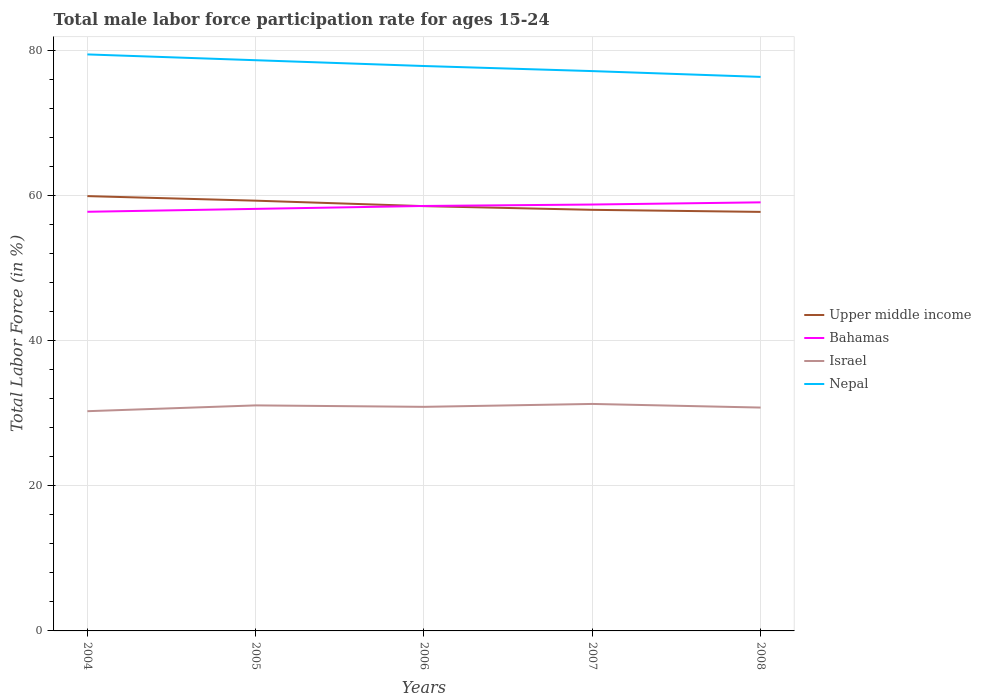Does the line corresponding to Nepal intersect with the line corresponding to Israel?
Offer a very short reply. No. Is the number of lines equal to the number of legend labels?
Provide a succinct answer. Yes. Across all years, what is the maximum male labor force participation rate in Upper middle income?
Ensure brevity in your answer.  57.78. In which year was the male labor force participation rate in Bahamas maximum?
Your answer should be very brief. 2004. What is the total male labor force participation rate in Bahamas in the graph?
Your answer should be compact. -0.6. What is the difference between the highest and the second highest male labor force participation rate in Nepal?
Ensure brevity in your answer.  3.1. What is the difference between the highest and the lowest male labor force participation rate in Bahamas?
Make the answer very short. 3. Is the male labor force participation rate in Upper middle income strictly greater than the male labor force participation rate in Nepal over the years?
Provide a short and direct response. Yes. What is the difference between two consecutive major ticks on the Y-axis?
Make the answer very short. 20. Does the graph contain grids?
Provide a succinct answer. Yes. Where does the legend appear in the graph?
Provide a succinct answer. Center right. What is the title of the graph?
Provide a succinct answer. Total male labor force participation rate for ages 15-24. Does "Paraguay" appear as one of the legend labels in the graph?
Offer a terse response. No. What is the label or title of the X-axis?
Offer a terse response. Years. What is the Total Labor Force (in %) in Upper middle income in 2004?
Offer a terse response. 59.96. What is the Total Labor Force (in %) of Bahamas in 2004?
Offer a very short reply. 57.8. What is the Total Labor Force (in %) in Israel in 2004?
Provide a succinct answer. 30.3. What is the Total Labor Force (in %) of Nepal in 2004?
Your answer should be very brief. 79.5. What is the Total Labor Force (in %) in Upper middle income in 2005?
Your answer should be compact. 59.33. What is the Total Labor Force (in %) of Bahamas in 2005?
Keep it short and to the point. 58.2. What is the Total Labor Force (in %) of Israel in 2005?
Make the answer very short. 31.1. What is the Total Labor Force (in %) in Nepal in 2005?
Ensure brevity in your answer.  78.7. What is the Total Labor Force (in %) in Upper middle income in 2006?
Make the answer very short. 58.58. What is the Total Labor Force (in %) of Bahamas in 2006?
Your answer should be very brief. 58.6. What is the Total Labor Force (in %) in Israel in 2006?
Offer a very short reply. 30.9. What is the Total Labor Force (in %) in Nepal in 2006?
Your answer should be very brief. 77.9. What is the Total Labor Force (in %) in Upper middle income in 2007?
Provide a succinct answer. 58.07. What is the Total Labor Force (in %) of Bahamas in 2007?
Provide a succinct answer. 58.8. What is the Total Labor Force (in %) of Israel in 2007?
Make the answer very short. 31.3. What is the Total Labor Force (in %) of Nepal in 2007?
Give a very brief answer. 77.2. What is the Total Labor Force (in %) of Upper middle income in 2008?
Your response must be concise. 57.78. What is the Total Labor Force (in %) of Bahamas in 2008?
Ensure brevity in your answer.  59.1. What is the Total Labor Force (in %) of Israel in 2008?
Your answer should be compact. 30.8. What is the Total Labor Force (in %) in Nepal in 2008?
Ensure brevity in your answer.  76.4. Across all years, what is the maximum Total Labor Force (in %) in Upper middle income?
Offer a very short reply. 59.96. Across all years, what is the maximum Total Labor Force (in %) in Bahamas?
Ensure brevity in your answer.  59.1. Across all years, what is the maximum Total Labor Force (in %) in Israel?
Keep it short and to the point. 31.3. Across all years, what is the maximum Total Labor Force (in %) of Nepal?
Your answer should be very brief. 79.5. Across all years, what is the minimum Total Labor Force (in %) in Upper middle income?
Your answer should be very brief. 57.78. Across all years, what is the minimum Total Labor Force (in %) in Bahamas?
Keep it short and to the point. 57.8. Across all years, what is the minimum Total Labor Force (in %) in Israel?
Your answer should be very brief. 30.3. Across all years, what is the minimum Total Labor Force (in %) in Nepal?
Your answer should be compact. 76.4. What is the total Total Labor Force (in %) of Upper middle income in the graph?
Keep it short and to the point. 293.72. What is the total Total Labor Force (in %) in Bahamas in the graph?
Provide a succinct answer. 292.5. What is the total Total Labor Force (in %) in Israel in the graph?
Offer a terse response. 154.4. What is the total Total Labor Force (in %) in Nepal in the graph?
Ensure brevity in your answer.  389.7. What is the difference between the Total Labor Force (in %) in Upper middle income in 2004 and that in 2005?
Make the answer very short. 0.63. What is the difference between the Total Labor Force (in %) in Upper middle income in 2004 and that in 2006?
Keep it short and to the point. 1.38. What is the difference between the Total Labor Force (in %) of Bahamas in 2004 and that in 2006?
Make the answer very short. -0.8. What is the difference between the Total Labor Force (in %) in Nepal in 2004 and that in 2006?
Make the answer very short. 1.6. What is the difference between the Total Labor Force (in %) of Upper middle income in 2004 and that in 2007?
Offer a very short reply. 1.89. What is the difference between the Total Labor Force (in %) of Israel in 2004 and that in 2007?
Keep it short and to the point. -1. What is the difference between the Total Labor Force (in %) in Nepal in 2004 and that in 2007?
Your answer should be compact. 2.3. What is the difference between the Total Labor Force (in %) of Upper middle income in 2004 and that in 2008?
Your answer should be very brief. 2.17. What is the difference between the Total Labor Force (in %) in Bahamas in 2004 and that in 2008?
Provide a succinct answer. -1.3. What is the difference between the Total Labor Force (in %) of Israel in 2004 and that in 2008?
Provide a short and direct response. -0.5. What is the difference between the Total Labor Force (in %) of Upper middle income in 2005 and that in 2006?
Give a very brief answer. 0.75. What is the difference between the Total Labor Force (in %) in Bahamas in 2005 and that in 2006?
Offer a terse response. -0.4. What is the difference between the Total Labor Force (in %) in Upper middle income in 2005 and that in 2007?
Offer a very short reply. 1.26. What is the difference between the Total Labor Force (in %) of Nepal in 2005 and that in 2007?
Provide a short and direct response. 1.5. What is the difference between the Total Labor Force (in %) of Upper middle income in 2005 and that in 2008?
Offer a very short reply. 1.55. What is the difference between the Total Labor Force (in %) in Bahamas in 2005 and that in 2008?
Provide a short and direct response. -0.9. What is the difference between the Total Labor Force (in %) of Nepal in 2005 and that in 2008?
Make the answer very short. 2.3. What is the difference between the Total Labor Force (in %) in Upper middle income in 2006 and that in 2007?
Offer a very short reply. 0.51. What is the difference between the Total Labor Force (in %) in Israel in 2006 and that in 2007?
Your response must be concise. -0.4. What is the difference between the Total Labor Force (in %) in Nepal in 2006 and that in 2007?
Ensure brevity in your answer.  0.7. What is the difference between the Total Labor Force (in %) of Upper middle income in 2006 and that in 2008?
Ensure brevity in your answer.  0.79. What is the difference between the Total Labor Force (in %) in Israel in 2006 and that in 2008?
Offer a terse response. 0.1. What is the difference between the Total Labor Force (in %) in Upper middle income in 2007 and that in 2008?
Your answer should be very brief. 0.28. What is the difference between the Total Labor Force (in %) in Bahamas in 2007 and that in 2008?
Ensure brevity in your answer.  -0.3. What is the difference between the Total Labor Force (in %) in Upper middle income in 2004 and the Total Labor Force (in %) in Bahamas in 2005?
Give a very brief answer. 1.76. What is the difference between the Total Labor Force (in %) of Upper middle income in 2004 and the Total Labor Force (in %) of Israel in 2005?
Offer a very short reply. 28.86. What is the difference between the Total Labor Force (in %) of Upper middle income in 2004 and the Total Labor Force (in %) of Nepal in 2005?
Your response must be concise. -18.74. What is the difference between the Total Labor Force (in %) of Bahamas in 2004 and the Total Labor Force (in %) of Israel in 2005?
Provide a short and direct response. 26.7. What is the difference between the Total Labor Force (in %) of Bahamas in 2004 and the Total Labor Force (in %) of Nepal in 2005?
Offer a very short reply. -20.9. What is the difference between the Total Labor Force (in %) in Israel in 2004 and the Total Labor Force (in %) in Nepal in 2005?
Your answer should be compact. -48.4. What is the difference between the Total Labor Force (in %) in Upper middle income in 2004 and the Total Labor Force (in %) in Bahamas in 2006?
Give a very brief answer. 1.36. What is the difference between the Total Labor Force (in %) in Upper middle income in 2004 and the Total Labor Force (in %) in Israel in 2006?
Keep it short and to the point. 29.06. What is the difference between the Total Labor Force (in %) in Upper middle income in 2004 and the Total Labor Force (in %) in Nepal in 2006?
Give a very brief answer. -17.94. What is the difference between the Total Labor Force (in %) in Bahamas in 2004 and the Total Labor Force (in %) in Israel in 2006?
Your answer should be compact. 26.9. What is the difference between the Total Labor Force (in %) in Bahamas in 2004 and the Total Labor Force (in %) in Nepal in 2006?
Offer a terse response. -20.1. What is the difference between the Total Labor Force (in %) of Israel in 2004 and the Total Labor Force (in %) of Nepal in 2006?
Offer a very short reply. -47.6. What is the difference between the Total Labor Force (in %) of Upper middle income in 2004 and the Total Labor Force (in %) of Bahamas in 2007?
Your response must be concise. 1.16. What is the difference between the Total Labor Force (in %) of Upper middle income in 2004 and the Total Labor Force (in %) of Israel in 2007?
Your answer should be very brief. 28.66. What is the difference between the Total Labor Force (in %) in Upper middle income in 2004 and the Total Labor Force (in %) in Nepal in 2007?
Keep it short and to the point. -17.24. What is the difference between the Total Labor Force (in %) in Bahamas in 2004 and the Total Labor Force (in %) in Nepal in 2007?
Your answer should be very brief. -19.4. What is the difference between the Total Labor Force (in %) of Israel in 2004 and the Total Labor Force (in %) of Nepal in 2007?
Offer a very short reply. -46.9. What is the difference between the Total Labor Force (in %) in Upper middle income in 2004 and the Total Labor Force (in %) in Bahamas in 2008?
Give a very brief answer. 0.86. What is the difference between the Total Labor Force (in %) of Upper middle income in 2004 and the Total Labor Force (in %) of Israel in 2008?
Your answer should be compact. 29.16. What is the difference between the Total Labor Force (in %) in Upper middle income in 2004 and the Total Labor Force (in %) in Nepal in 2008?
Your answer should be compact. -16.44. What is the difference between the Total Labor Force (in %) of Bahamas in 2004 and the Total Labor Force (in %) of Israel in 2008?
Make the answer very short. 27. What is the difference between the Total Labor Force (in %) of Bahamas in 2004 and the Total Labor Force (in %) of Nepal in 2008?
Offer a terse response. -18.6. What is the difference between the Total Labor Force (in %) of Israel in 2004 and the Total Labor Force (in %) of Nepal in 2008?
Ensure brevity in your answer.  -46.1. What is the difference between the Total Labor Force (in %) in Upper middle income in 2005 and the Total Labor Force (in %) in Bahamas in 2006?
Offer a terse response. 0.73. What is the difference between the Total Labor Force (in %) in Upper middle income in 2005 and the Total Labor Force (in %) in Israel in 2006?
Make the answer very short. 28.43. What is the difference between the Total Labor Force (in %) in Upper middle income in 2005 and the Total Labor Force (in %) in Nepal in 2006?
Make the answer very short. -18.57. What is the difference between the Total Labor Force (in %) of Bahamas in 2005 and the Total Labor Force (in %) of Israel in 2006?
Offer a very short reply. 27.3. What is the difference between the Total Labor Force (in %) of Bahamas in 2005 and the Total Labor Force (in %) of Nepal in 2006?
Offer a very short reply. -19.7. What is the difference between the Total Labor Force (in %) in Israel in 2005 and the Total Labor Force (in %) in Nepal in 2006?
Keep it short and to the point. -46.8. What is the difference between the Total Labor Force (in %) in Upper middle income in 2005 and the Total Labor Force (in %) in Bahamas in 2007?
Give a very brief answer. 0.53. What is the difference between the Total Labor Force (in %) in Upper middle income in 2005 and the Total Labor Force (in %) in Israel in 2007?
Provide a short and direct response. 28.03. What is the difference between the Total Labor Force (in %) in Upper middle income in 2005 and the Total Labor Force (in %) in Nepal in 2007?
Offer a very short reply. -17.87. What is the difference between the Total Labor Force (in %) of Bahamas in 2005 and the Total Labor Force (in %) of Israel in 2007?
Offer a very short reply. 26.9. What is the difference between the Total Labor Force (in %) in Bahamas in 2005 and the Total Labor Force (in %) in Nepal in 2007?
Your response must be concise. -19. What is the difference between the Total Labor Force (in %) in Israel in 2005 and the Total Labor Force (in %) in Nepal in 2007?
Your answer should be compact. -46.1. What is the difference between the Total Labor Force (in %) of Upper middle income in 2005 and the Total Labor Force (in %) of Bahamas in 2008?
Make the answer very short. 0.23. What is the difference between the Total Labor Force (in %) in Upper middle income in 2005 and the Total Labor Force (in %) in Israel in 2008?
Provide a short and direct response. 28.53. What is the difference between the Total Labor Force (in %) in Upper middle income in 2005 and the Total Labor Force (in %) in Nepal in 2008?
Ensure brevity in your answer.  -17.07. What is the difference between the Total Labor Force (in %) of Bahamas in 2005 and the Total Labor Force (in %) of Israel in 2008?
Provide a succinct answer. 27.4. What is the difference between the Total Labor Force (in %) in Bahamas in 2005 and the Total Labor Force (in %) in Nepal in 2008?
Your response must be concise. -18.2. What is the difference between the Total Labor Force (in %) of Israel in 2005 and the Total Labor Force (in %) of Nepal in 2008?
Offer a terse response. -45.3. What is the difference between the Total Labor Force (in %) of Upper middle income in 2006 and the Total Labor Force (in %) of Bahamas in 2007?
Your answer should be compact. -0.22. What is the difference between the Total Labor Force (in %) in Upper middle income in 2006 and the Total Labor Force (in %) in Israel in 2007?
Ensure brevity in your answer.  27.28. What is the difference between the Total Labor Force (in %) in Upper middle income in 2006 and the Total Labor Force (in %) in Nepal in 2007?
Keep it short and to the point. -18.62. What is the difference between the Total Labor Force (in %) of Bahamas in 2006 and the Total Labor Force (in %) of Israel in 2007?
Your response must be concise. 27.3. What is the difference between the Total Labor Force (in %) of Bahamas in 2006 and the Total Labor Force (in %) of Nepal in 2007?
Provide a succinct answer. -18.6. What is the difference between the Total Labor Force (in %) in Israel in 2006 and the Total Labor Force (in %) in Nepal in 2007?
Provide a succinct answer. -46.3. What is the difference between the Total Labor Force (in %) in Upper middle income in 2006 and the Total Labor Force (in %) in Bahamas in 2008?
Give a very brief answer. -0.52. What is the difference between the Total Labor Force (in %) in Upper middle income in 2006 and the Total Labor Force (in %) in Israel in 2008?
Your answer should be compact. 27.78. What is the difference between the Total Labor Force (in %) in Upper middle income in 2006 and the Total Labor Force (in %) in Nepal in 2008?
Provide a short and direct response. -17.82. What is the difference between the Total Labor Force (in %) of Bahamas in 2006 and the Total Labor Force (in %) of Israel in 2008?
Your answer should be very brief. 27.8. What is the difference between the Total Labor Force (in %) in Bahamas in 2006 and the Total Labor Force (in %) in Nepal in 2008?
Your answer should be compact. -17.8. What is the difference between the Total Labor Force (in %) of Israel in 2006 and the Total Labor Force (in %) of Nepal in 2008?
Your response must be concise. -45.5. What is the difference between the Total Labor Force (in %) in Upper middle income in 2007 and the Total Labor Force (in %) in Bahamas in 2008?
Ensure brevity in your answer.  -1.03. What is the difference between the Total Labor Force (in %) in Upper middle income in 2007 and the Total Labor Force (in %) in Israel in 2008?
Your response must be concise. 27.27. What is the difference between the Total Labor Force (in %) of Upper middle income in 2007 and the Total Labor Force (in %) of Nepal in 2008?
Offer a terse response. -18.33. What is the difference between the Total Labor Force (in %) in Bahamas in 2007 and the Total Labor Force (in %) in Nepal in 2008?
Provide a succinct answer. -17.6. What is the difference between the Total Labor Force (in %) of Israel in 2007 and the Total Labor Force (in %) of Nepal in 2008?
Your answer should be compact. -45.1. What is the average Total Labor Force (in %) in Upper middle income per year?
Make the answer very short. 58.74. What is the average Total Labor Force (in %) of Bahamas per year?
Give a very brief answer. 58.5. What is the average Total Labor Force (in %) of Israel per year?
Offer a very short reply. 30.88. What is the average Total Labor Force (in %) of Nepal per year?
Your answer should be very brief. 77.94. In the year 2004, what is the difference between the Total Labor Force (in %) of Upper middle income and Total Labor Force (in %) of Bahamas?
Your answer should be compact. 2.16. In the year 2004, what is the difference between the Total Labor Force (in %) in Upper middle income and Total Labor Force (in %) in Israel?
Keep it short and to the point. 29.66. In the year 2004, what is the difference between the Total Labor Force (in %) in Upper middle income and Total Labor Force (in %) in Nepal?
Your response must be concise. -19.54. In the year 2004, what is the difference between the Total Labor Force (in %) of Bahamas and Total Labor Force (in %) of Nepal?
Keep it short and to the point. -21.7. In the year 2004, what is the difference between the Total Labor Force (in %) in Israel and Total Labor Force (in %) in Nepal?
Offer a very short reply. -49.2. In the year 2005, what is the difference between the Total Labor Force (in %) of Upper middle income and Total Labor Force (in %) of Bahamas?
Ensure brevity in your answer.  1.13. In the year 2005, what is the difference between the Total Labor Force (in %) of Upper middle income and Total Labor Force (in %) of Israel?
Give a very brief answer. 28.23. In the year 2005, what is the difference between the Total Labor Force (in %) of Upper middle income and Total Labor Force (in %) of Nepal?
Keep it short and to the point. -19.37. In the year 2005, what is the difference between the Total Labor Force (in %) of Bahamas and Total Labor Force (in %) of Israel?
Keep it short and to the point. 27.1. In the year 2005, what is the difference between the Total Labor Force (in %) of Bahamas and Total Labor Force (in %) of Nepal?
Your answer should be compact. -20.5. In the year 2005, what is the difference between the Total Labor Force (in %) in Israel and Total Labor Force (in %) in Nepal?
Give a very brief answer. -47.6. In the year 2006, what is the difference between the Total Labor Force (in %) of Upper middle income and Total Labor Force (in %) of Bahamas?
Make the answer very short. -0.02. In the year 2006, what is the difference between the Total Labor Force (in %) in Upper middle income and Total Labor Force (in %) in Israel?
Your answer should be very brief. 27.68. In the year 2006, what is the difference between the Total Labor Force (in %) of Upper middle income and Total Labor Force (in %) of Nepal?
Make the answer very short. -19.32. In the year 2006, what is the difference between the Total Labor Force (in %) in Bahamas and Total Labor Force (in %) in Israel?
Keep it short and to the point. 27.7. In the year 2006, what is the difference between the Total Labor Force (in %) in Bahamas and Total Labor Force (in %) in Nepal?
Your answer should be very brief. -19.3. In the year 2006, what is the difference between the Total Labor Force (in %) of Israel and Total Labor Force (in %) of Nepal?
Provide a succinct answer. -47. In the year 2007, what is the difference between the Total Labor Force (in %) in Upper middle income and Total Labor Force (in %) in Bahamas?
Ensure brevity in your answer.  -0.73. In the year 2007, what is the difference between the Total Labor Force (in %) in Upper middle income and Total Labor Force (in %) in Israel?
Keep it short and to the point. 26.77. In the year 2007, what is the difference between the Total Labor Force (in %) of Upper middle income and Total Labor Force (in %) of Nepal?
Your response must be concise. -19.13. In the year 2007, what is the difference between the Total Labor Force (in %) in Bahamas and Total Labor Force (in %) in Nepal?
Keep it short and to the point. -18.4. In the year 2007, what is the difference between the Total Labor Force (in %) in Israel and Total Labor Force (in %) in Nepal?
Offer a very short reply. -45.9. In the year 2008, what is the difference between the Total Labor Force (in %) of Upper middle income and Total Labor Force (in %) of Bahamas?
Provide a short and direct response. -1.32. In the year 2008, what is the difference between the Total Labor Force (in %) of Upper middle income and Total Labor Force (in %) of Israel?
Provide a succinct answer. 26.98. In the year 2008, what is the difference between the Total Labor Force (in %) in Upper middle income and Total Labor Force (in %) in Nepal?
Your response must be concise. -18.62. In the year 2008, what is the difference between the Total Labor Force (in %) in Bahamas and Total Labor Force (in %) in Israel?
Offer a terse response. 28.3. In the year 2008, what is the difference between the Total Labor Force (in %) of Bahamas and Total Labor Force (in %) of Nepal?
Offer a terse response. -17.3. In the year 2008, what is the difference between the Total Labor Force (in %) of Israel and Total Labor Force (in %) of Nepal?
Give a very brief answer. -45.6. What is the ratio of the Total Labor Force (in %) of Upper middle income in 2004 to that in 2005?
Provide a short and direct response. 1.01. What is the ratio of the Total Labor Force (in %) in Bahamas in 2004 to that in 2005?
Offer a very short reply. 0.99. What is the ratio of the Total Labor Force (in %) of Israel in 2004 to that in 2005?
Provide a short and direct response. 0.97. What is the ratio of the Total Labor Force (in %) of Nepal in 2004 to that in 2005?
Give a very brief answer. 1.01. What is the ratio of the Total Labor Force (in %) of Upper middle income in 2004 to that in 2006?
Your answer should be very brief. 1.02. What is the ratio of the Total Labor Force (in %) in Bahamas in 2004 to that in 2006?
Ensure brevity in your answer.  0.99. What is the ratio of the Total Labor Force (in %) in Israel in 2004 to that in 2006?
Provide a succinct answer. 0.98. What is the ratio of the Total Labor Force (in %) in Nepal in 2004 to that in 2006?
Your answer should be compact. 1.02. What is the ratio of the Total Labor Force (in %) in Upper middle income in 2004 to that in 2007?
Offer a very short reply. 1.03. What is the ratio of the Total Labor Force (in %) of Israel in 2004 to that in 2007?
Ensure brevity in your answer.  0.97. What is the ratio of the Total Labor Force (in %) of Nepal in 2004 to that in 2007?
Give a very brief answer. 1.03. What is the ratio of the Total Labor Force (in %) in Upper middle income in 2004 to that in 2008?
Offer a terse response. 1.04. What is the ratio of the Total Labor Force (in %) of Bahamas in 2004 to that in 2008?
Your answer should be compact. 0.98. What is the ratio of the Total Labor Force (in %) in Israel in 2004 to that in 2008?
Provide a succinct answer. 0.98. What is the ratio of the Total Labor Force (in %) in Nepal in 2004 to that in 2008?
Give a very brief answer. 1.04. What is the ratio of the Total Labor Force (in %) of Upper middle income in 2005 to that in 2006?
Provide a short and direct response. 1.01. What is the ratio of the Total Labor Force (in %) in Bahamas in 2005 to that in 2006?
Keep it short and to the point. 0.99. What is the ratio of the Total Labor Force (in %) of Nepal in 2005 to that in 2006?
Provide a succinct answer. 1.01. What is the ratio of the Total Labor Force (in %) of Upper middle income in 2005 to that in 2007?
Make the answer very short. 1.02. What is the ratio of the Total Labor Force (in %) of Nepal in 2005 to that in 2007?
Ensure brevity in your answer.  1.02. What is the ratio of the Total Labor Force (in %) of Upper middle income in 2005 to that in 2008?
Offer a terse response. 1.03. What is the ratio of the Total Labor Force (in %) in Bahamas in 2005 to that in 2008?
Ensure brevity in your answer.  0.98. What is the ratio of the Total Labor Force (in %) in Israel in 2005 to that in 2008?
Make the answer very short. 1.01. What is the ratio of the Total Labor Force (in %) in Nepal in 2005 to that in 2008?
Your response must be concise. 1.03. What is the ratio of the Total Labor Force (in %) of Upper middle income in 2006 to that in 2007?
Offer a terse response. 1.01. What is the ratio of the Total Labor Force (in %) of Israel in 2006 to that in 2007?
Make the answer very short. 0.99. What is the ratio of the Total Labor Force (in %) in Nepal in 2006 to that in 2007?
Provide a short and direct response. 1.01. What is the ratio of the Total Labor Force (in %) of Upper middle income in 2006 to that in 2008?
Your answer should be compact. 1.01. What is the ratio of the Total Labor Force (in %) of Bahamas in 2006 to that in 2008?
Offer a very short reply. 0.99. What is the ratio of the Total Labor Force (in %) of Nepal in 2006 to that in 2008?
Your answer should be compact. 1.02. What is the ratio of the Total Labor Force (in %) of Upper middle income in 2007 to that in 2008?
Offer a terse response. 1. What is the ratio of the Total Labor Force (in %) in Israel in 2007 to that in 2008?
Your answer should be very brief. 1.02. What is the ratio of the Total Labor Force (in %) in Nepal in 2007 to that in 2008?
Give a very brief answer. 1.01. What is the difference between the highest and the second highest Total Labor Force (in %) of Upper middle income?
Your answer should be compact. 0.63. What is the difference between the highest and the second highest Total Labor Force (in %) in Nepal?
Give a very brief answer. 0.8. What is the difference between the highest and the lowest Total Labor Force (in %) in Upper middle income?
Your response must be concise. 2.17. 